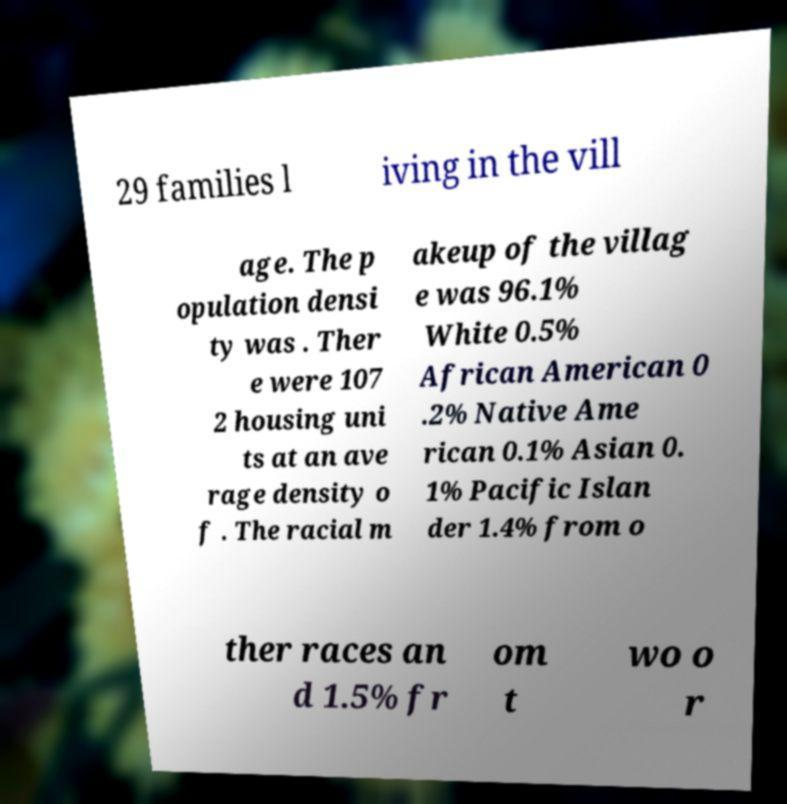For documentation purposes, I need the text within this image transcribed. Could you provide that? 29 families l iving in the vill age. The p opulation densi ty was . Ther e were 107 2 housing uni ts at an ave rage density o f . The racial m akeup of the villag e was 96.1% White 0.5% African American 0 .2% Native Ame rican 0.1% Asian 0. 1% Pacific Islan der 1.4% from o ther races an d 1.5% fr om t wo o r 